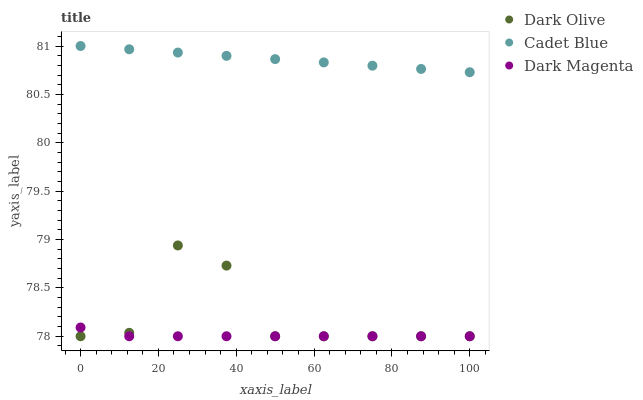Does Dark Magenta have the minimum area under the curve?
Answer yes or no. Yes. Does Cadet Blue have the maximum area under the curve?
Answer yes or no. Yes. Does Dark Olive have the minimum area under the curve?
Answer yes or no. No. Does Dark Olive have the maximum area under the curve?
Answer yes or no. No. Is Cadet Blue the smoothest?
Answer yes or no. Yes. Is Dark Olive the roughest?
Answer yes or no. Yes. Is Dark Magenta the smoothest?
Answer yes or no. No. Is Dark Magenta the roughest?
Answer yes or no. No. Does Dark Olive have the lowest value?
Answer yes or no. Yes. Does Cadet Blue have the highest value?
Answer yes or no. Yes. Does Dark Olive have the highest value?
Answer yes or no. No. Is Dark Olive less than Cadet Blue?
Answer yes or no. Yes. Is Cadet Blue greater than Dark Magenta?
Answer yes or no. Yes. Does Dark Magenta intersect Dark Olive?
Answer yes or no. Yes. Is Dark Magenta less than Dark Olive?
Answer yes or no. No. Is Dark Magenta greater than Dark Olive?
Answer yes or no. No. Does Dark Olive intersect Cadet Blue?
Answer yes or no. No. 